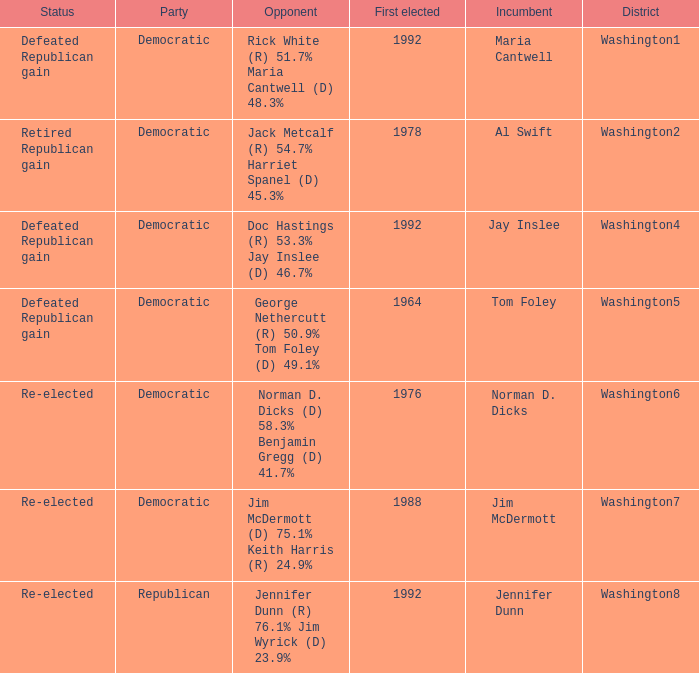Parse the table in full. {'header': ['Status', 'Party', 'Opponent', 'First elected', 'Incumbent', 'District'], 'rows': [['Defeated Republican gain', 'Democratic', 'Rick White (R) 51.7% Maria Cantwell (D) 48.3%', '1992', 'Maria Cantwell', 'Washington1'], ['Retired Republican gain', 'Democratic', 'Jack Metcalf (R) 54.7% Harriet Spanel (D) 45.3%', '1978', 'Al Swift', 'Washington2'], ['Defeated Republican gain', 'Democratic', 'Doc Hastings (R) 53.3% Jay Inslee (D) 46.7%', '1992', 'Jay Inslee', 'Washington4'], ['Defeated Republican gain', 'Democratic', 'George Nethercutt (R) 50.9% Tom Foley (D) 49.1%', '1964', 'Tom Foley', 'Washington5'], ['Re-elected', 'Democratic', 'Norman D. Dicks (D) 58.3% Benjamin Gregg (D) 41.7%', '1976', 'Norman D. Dicks', 'Washington6'], ['Re-elected', 'Democratic', 'Jim McDermott (D) 75.1% Keith Harris (R) 24.9%', '1988', 'Jim McDermott', 'Washington7'], ['Re-elected', 'Republican', 'Jennifer Dunn (R) 76.1% Jim Wyrick (D) 23.9%', '1992', 'Jennifer Dunn', 'Washington8']]} What was the result of the election of doc hastings (r) 53.3% jay inslee (d) 46.7% Defeated Republican gain. 